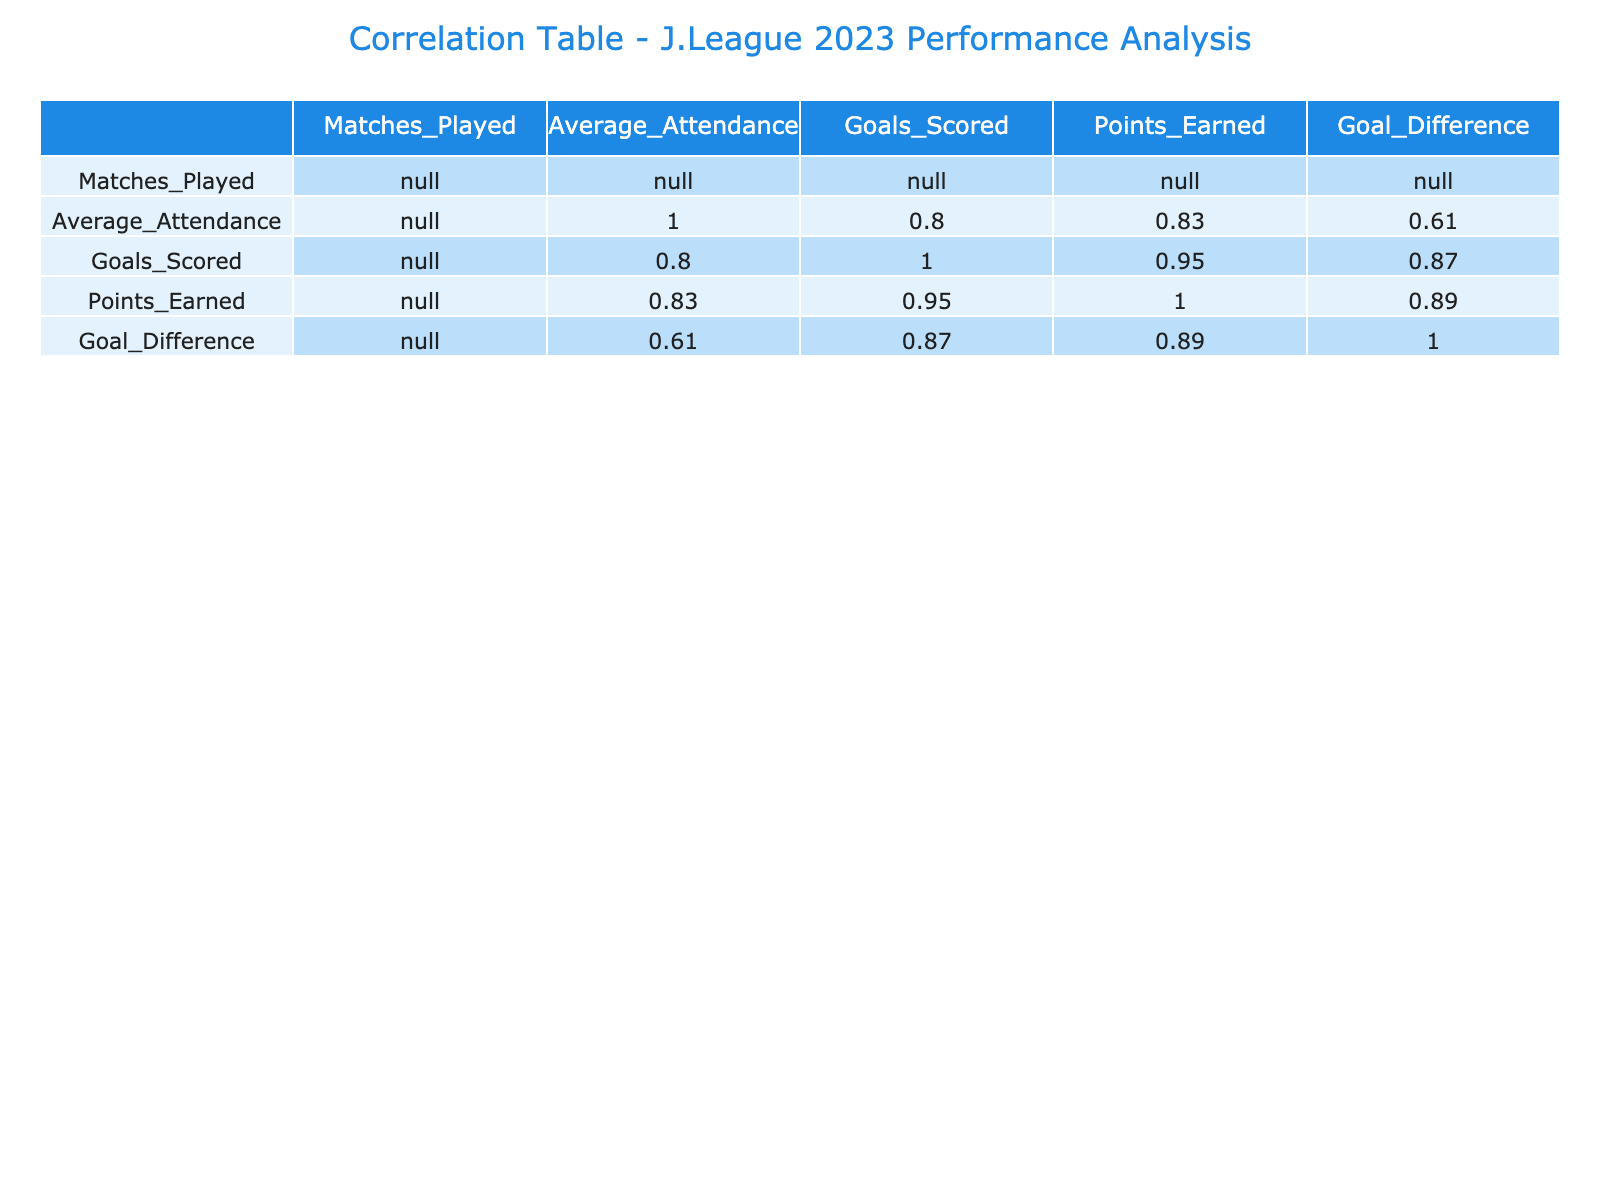What is the highest average attendance in the table? Looking through the Average_Attendance column, I see that the highest value is 29372, which belongs to the Urawa Red Diamonds.
Answer: 29372 Which team scored the most goals? In the Goals_Scored column, Kawasaki Frontale has the highest total with 55 goals, making them the top scoring team.
Answer: 55 Is there a correlation between average attendance and points earned? To determine this, we examine the correlation value between Average_Attendance and Points_Earned in the table. The correlation coefficient is not explicitly stated, but visually the teams with higher attendance mainly have higher points, indicating a likely positive correlation.
Answer: Yes What is the goal difference of FC Machida Zelvia? FC Machida Zelvia's goal difference is specified in the Goal_Difference column, which shows a value of 7.
Answer: 7 Which two teams combined had the lowest total points earned? Adding the points for Sagan Tosu (32) and Vissel Kobe (46) gives a total of 78 points, which is lower than any other possible combination of teams.
Answer: 78 What is the average number of goals scored across all teams? To find the average, I sum the Goals_Scored column (35 + 52 + 55 + 45 + 47 + 48 + 41 + 50 + 38 + 36 = 397) and divide by the number of teams (10). The average is 397/10 = 39.7.
Answer: 39.7 Does FC Machida Zelvia have a positive goal difference? FC Machida Zelvia has a goal difference of 7, which is greater than zero, indicating a positive goal difference.
Answer: Yes Which team has the lowest average attendance and how many matches did they play? Sagan Tosu has the lowest average attendance of 6710, and they played 30 matches, as confirmed in the Matches_Played column.
Answer: 30 If we compare Gamba Osaka and Cerezo Osaka, which team has a better goal difference? For Gamba Osaka, the goal difference is 5, while for Cerezo Osaka, it is 15. Since 15 is greater than 5, Cerezo Osaka has a better goal difference.
Answer: Cerezo Osaka 